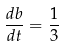Convert formula to latex. <formula><loc_0><loc_0><loc_500><loc_500>\frac { d b } { d t } = \frac { 1 } { 3 }</formula> 